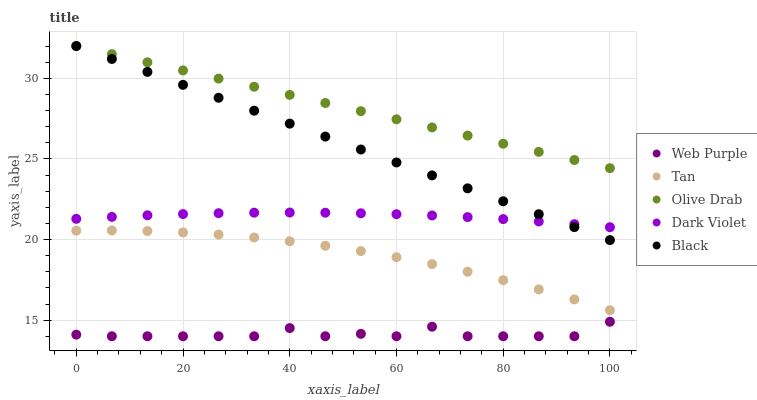Does Web Purple have the minimum area under the curve?
Answer yes or no. Yes. Does Olive Drab have the maximum area under the curve?
Answer yes or no. Yes. Does Dark Violet have the minimum area under the curve?
Answer yes or no. No. Does Dark Violet have the maximum area under the curve?
Answer yes or no. No. Is Black the smoothest?
Answer yes or no. Yes. Is Web Purple the roughest?
Answer yes or no. Yes. Is Dark Violet the smoothest?
Answer yes or no. No. Is Dark Violet the roughest?
Answer yes or no. No. Does Web Purple have the lowest value?
Answer yes or no. Yes. Does Dark Violet have the lowest value?
Answer yes or no. No. Does Olive Drab have the highest value?
Answer yes or no. Yes. Does Dark Violet have the highest value?
Answer yes or no. No. Is Tan less than Dark Violet?
Answer yes or no. Yes. Is Black greater than Web Purple?
Answer yes or no. Yes. Does Black intersect Olive Drab?
Answer yes or no. Yes. Is Black less than Olive Drab?
Answer yes or no. No. Is Black greater than Olive Drab?
Answer yes or no. No. Does Tan intersect Dark Violet?
Answer yes or no. No. 